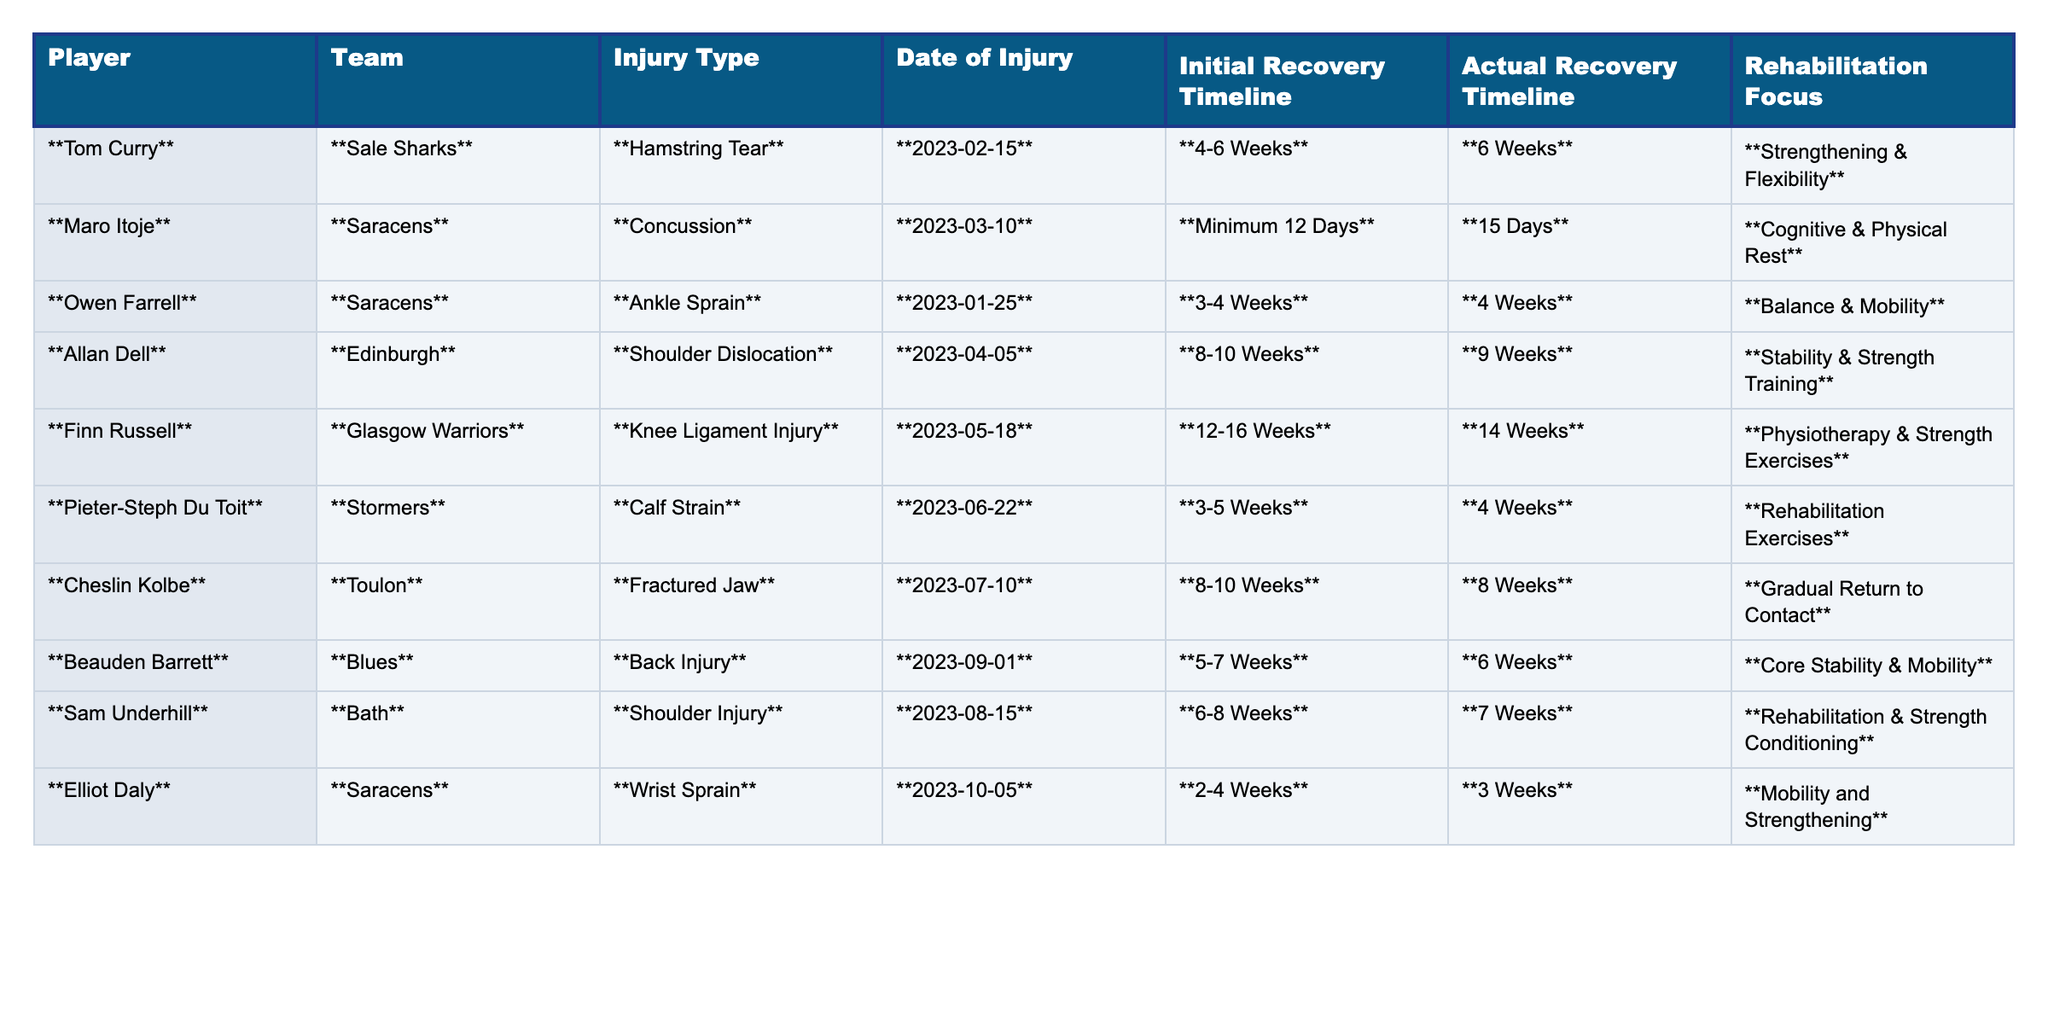What injury did Tom Curry suffer? According to the table, Tom Curry suffered a hamstring tear.
Answer: Hamstring tear What is the actual recovery timeline for Owen Farrell? The table states Owen Farrell's actual recovery timeline is 4 weeks.
Answer: 4 weeks Did Cheslin Kolbe's recovery take longer than the initial timeline? Yes, Cheslin Kolbe's actual recovery timeline of 8 weeks is shorter than the initial 8-10 weeks.
Answer: Yes Who had a wrist sprain and how long did it take to recover? The table shows that Elliot Daly had a wrist sprain, and his actual recovery took 3 weeks.
Answer: Elliot Daly, 3 weeks What is the average actual recovery timeline for the players listed? First, sum the actual recovery timelines: 6 + 15 + 4 + 9 + 14 + 4 + 8 + 6 + 7 + 3 = 76. There are 10 players, so the average is 76 / 10 = 7.6 weeks.
Answer: 7.6 weeks Which player had the longest initial recovery timeline? Finn Russell had the longest initial recovery timeline of 12-16 weeks.
Answer: Finn Russell Did any player recover in a shorter time than they initially expected? Yes, Owen Farrell recovered in 4 weeks, which is within his initial timeline of 3-4 weeks.
Answer: Yes What rehabilitation focus is associated with Sam Underhill? The table indicates that Sam Underhill's rehabilitation focus is on rehabilitation and strength conditioning.
Answer: Rehabilitation & Strength Conditioning Compare the initial and actual recovery timelines of Allan Dell. Allan Dell's initial recovery timeline was 8-10 weeks, but he actually recovered in 9 weeks, which is within his initial estimate.
Answer: Within initial estimate Was Maro Itoje's actual recovery timeline 15 days longer than the minimum provided? Yes, Maro Itoje's actual recovery of 15 days is indeed longer than the minimum expected of 12 days.
Answer: Yes 